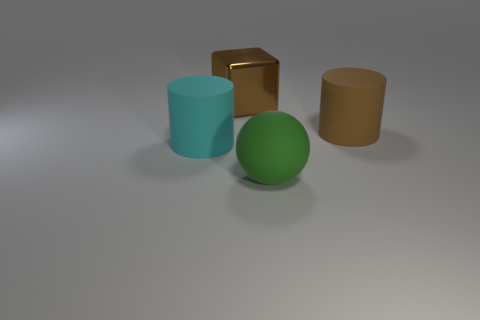Add 1 large yellow balls. How many objects exist? 5 Subtract all brown cylinders. How many cylinders are left? 1 Subtract 1 blocks. How many blocks are left? 0 Subtract all spheres. How many objects are left? 3 Subtract all brown balls. How many brown cylinders are left? 1 Subtract all brown rubber cylinders. Subtract all blue balls. How many objects are left? 3 Add 3 metal blocks. How many metal blocks are left? 4 Add 2 big cyan rubber cylinders. How many big cyan rubber cylinders exist? 3 Subtract 0 blue cylinders. How many objects are left? 4 Subtract all gray spheres. Subtract all red cylinders. How many spheres are left? 1 